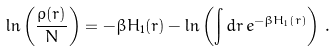Convert formula to latex. <formula><loc_0><loc_0><loc_500><loc_500>\ln \left ( \frac { \rho ( { r } ) } { N } \right ) = - \beta H _ { 1 } ( { r } ) - \ln \left ( \int d { r } \, e ^ { - \beta H _ { 1 } ( { r } ) } \right ) \, .</formula> 